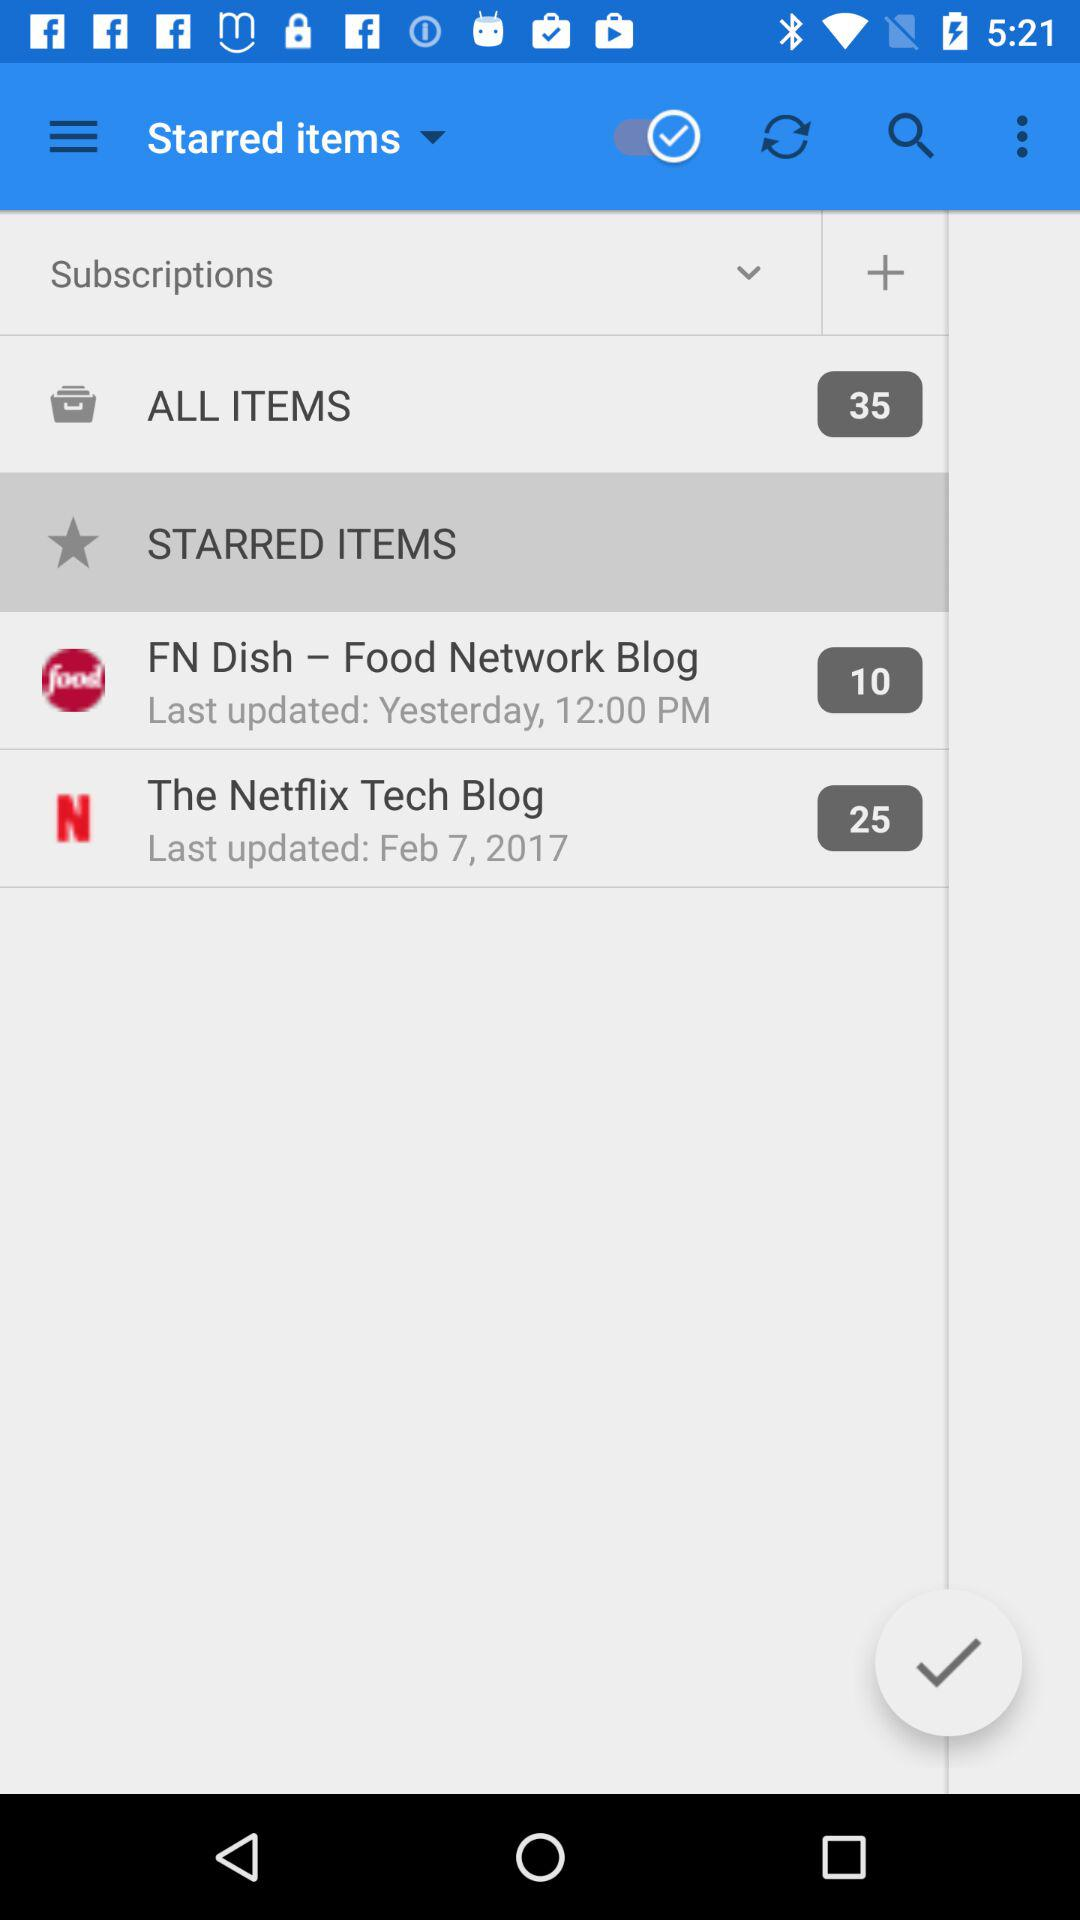How many stars are given to FN Dish-Food Network Blog?
When the provided information is insufficient, respond with <no answer>. <no answer> 